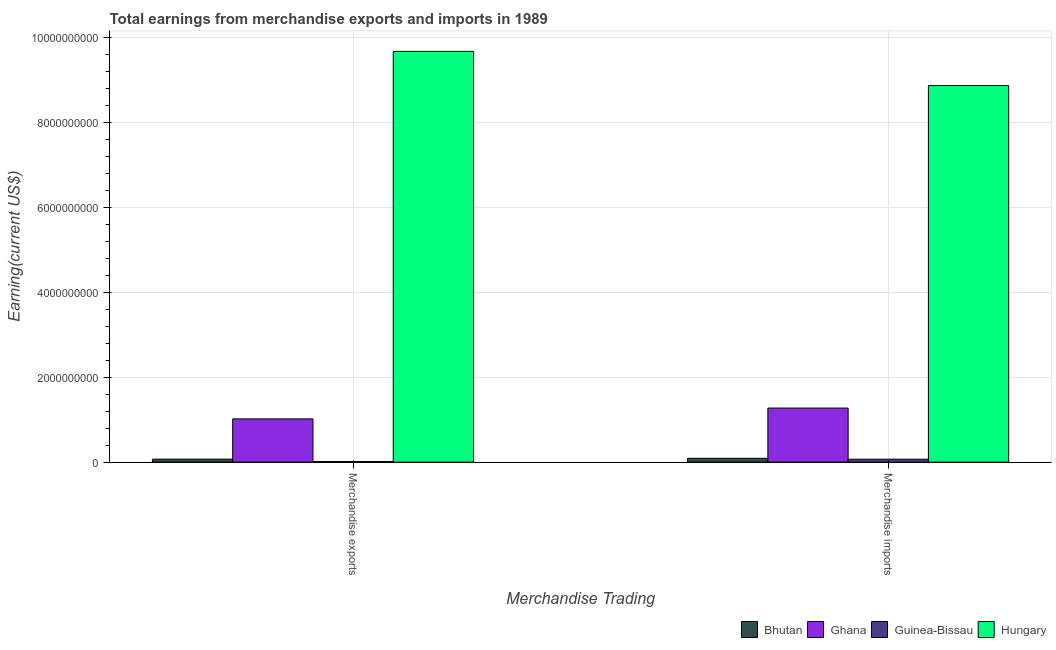What is the label of the 2nd group of bars from the left?
Make the answer very short. Merchandise imports. What is the earnings from merchandise exports in Guinea-Bissau?
Offer a terse response. 1.40e+07. Across all countries, what is the maximum earnings from merchandise exports?
Your response must be concise. 9.67e+09. Across all countries, what is the minimum earnings from merchandise imports?
Offer a very short reply. 6.90e+07. In which country was the earnings from merchandise exports maximum?
Give a very brief answer. Hungary. In which country was the earnings from merchandise exports minimum?
Ensure brevity in your answer.  Guinea-Bissau. What is the total earnings from merchandise imports in the graph?
Make the answer very short. 1.03e+1. What is the difference between the earnings from merchandise imports in Bhutan and that in Guinea-Bissau?
Your response must be concise. 2.10e+07. What is the difference between the earnings from merchandise exports in Guinea-Bissau and the earnings from merchandise imports in Ghana?
Keep it short and to the point. -1.26e+09. What is the average earnings from merchandise imports per country?
Offer a very short reply. 2.57e+09. What is the difference between the earnings from merchandise imports and earnings from merchandise exports in Bhutan?
Provide a short and direct response. 2.00e+07. In how many countries, is the earnings from merchandise exports greater than 6000000000 US$?
Your answer should be compact. 1. What is the ratio of the earnings from merchandise exports in Ghana to that in Bhutan?
Offer a terse response. 14.54. Is the earnings from merchandise imports in Ghana less than that in Bhutan?
Your response must be concise. No. In how many countries, is the earnings from merchandise exports greater than the average earnings from merchandise exports taken over all countries?
Provide a succinct answer. 1. What does the 1st bar from the left in Merchandise imports represents?
Give a very brief answer. Bhutan. What does the 2nd bar from the right in Merchandise exports represents?
Your answer should be very brief. Guinea-Bissau. How many countries are there in the graph?
Provide a succinct answer. 4. What is the difference between two consecutive major ticks on the Y-axis?
Make the answer very short. 2.00e+09. Where does the legend appear in the graph?
Ensure brevity in your answer.  Bottom right. How many legend labels are there?
Make the answer very short. 4. What is the title of the graph?
Give a very brief answer. Total earnings from merchandise exports and imports in 1989. Does "Hong Kong" appear as one of the legend labels in the graph?
Provide a succinct answer. No. What is the label or title of the X-axis?
Your response must be concise. Merchandise Trading. What is the label or title of the Y-axis?
Provide a short and direct response. Earning(current US$). What is the Earning(current US$) in Bhutan in Merchandise exports?
Give a very brief answer. 7.00e+07. What is the Earning(current US$) of Ghana in Merchandise exports?
Offer a terse response. 1.02e+09. What is the Earning(current US$) of Guinea-Bissau in Merchandise exports?
Your answer should be compact. 1.40e+07. What is the Earning(current US$) in Hungary in Merchandise exports?
Your answer should be very brief. 9.67e+09. What is the Earning(current US$) in Bhutan in Merchandise imports?
Provide a succinct answer. 9.00e+07. What is the Earning(current US$) in Ghana in Merchandise imports?
Offer a very short reply. 1.27e+09. What is the Earning(current US$) in Guinea-Bissau in Merchandise imports?
Provide a short and direct response. 6.90e+07. What is the Earning(current US$) of Hungary in Merchandise imports?
Your answer should be very brief. 8.86e+09. Across all Merchandise Trading, what is the maximum Earning(current US$) in Bhutan?
Provide a short and direct response. 9.00e+07. Across all Merchandise Trading, what is the maximum Earning(current US$) of Ghana?
Give a very brief answer. 1.27e+09. Across all Merchandise Trading, what is the maximum Earning(current US$) in Guinea-Bissau?
Your answer should be compact. 6.90e+07. Across all Merchandise Trading, what is the maximum Earning(current US$) of Hungary?
Offer a very short reply. 9.67e+09. Across all Merchandise Trading, what is the minimum Earning(current US$) of Bhutan?
Offer a terse response. 7.00e+07. Across all Merchandise Trading, what is the minimum Earning(current US$) in Ghana?
Keep it short and to the point. 1.02e+09. Across all Merchandise Trading, what is the minimum Earning(current US$) in Guinea-Bissau?
Offer a very short reply. 1.40e+07. Across all Merchandise Trading, what is the minimum Earning(current US$) of Hungary?
Provide a short and direct response. 8.86e+09. What is the total Earning(current US$) in Bhutan in the graph?
Your response must be concise. 1.60e+08. What is the total Earning(current US$) of Ghana in the graph?
Provide a succinct answer. 2.29e+09. What is the total Earning(current US$) in Guinea-Bissau in the graph?
Your answer should be compact. 8.30e+07. What is the total Earning(current US$) in Hungary in the graph?
Your response must be concise. 1.85e+1. What is the difference between the Earning(current US$) in Bhutan in Merchandise exports and that in Merchandise imports?
Keep it short and to the point. -2.00e+07. What is the difference between the Earning(current US$) of Ghana in Merchandise exports and that in Merchandise imports?
Provide a short and direct response. -2.55e+08. What is the difference between the Earning(current US$) of Guinea-Bissau in Merchandise exports and that in Merchandise imports?
Your answer should be compact. -5.50e+07. What is the difference between the Earning(current US$) of Hungary in Merchandise exports and that in Merchandise imports?
Your answer should be compact. 8.05e+08. What is the difference between the Earning(current US$) of Bhutan in Merchandise exports and the Earning(current US$) of Ghana in Merchandise imports?
Give a very brief answer. -1.20e+09. What is the difference between the Earning(current US$) in Bhutan in Merchandise exports and the Earning(current US$) in Guinea-Bissau in Merchandise imports?
Give a very brief answer. 1.00e+06. What is the difference between the Earning(current US$) in Bhutan in Merchandise exports and the Earning(current US$) in Hungary in Merchandise imports?
Ensure brevity in your answer.  -8.80e+09. What is the difference between the Earning(current US$) in Ghana in Merchandise exports and the Earning(current US$) in Guinea-Bissau in Merchandise imports?
Provide a short and direct response. 9.49e+08. What is the difference between the Earning(current US$) of Ghana in Merchandise exports and the Earning(current US$) of Hungary in Merchandise imports?
Make the answer very short. -7.85e+09. What is the difference between the Earning(current US$) of Guinea-Bissau in Merchandise exports and the Earning(current US$) of Hungary in Merchandise imports?
Keep it short and to the point. -8.85e+09. What is the average Earning(current US$) of Bhutan per Merchandise Trading?
Your response must be concise. 8.00e+07. What is the average Earning(current US$) of Ghana per Merchandise Trading?
Provide a short and direct response. 1.15e+09. What is the average Earning(current US$) in Guinea-Bissau per Merchandise Trading?
Offer a terse response. 4.15e+07. What is the average Earning(current US$) in Hungary per Merchandise Trading?
Your answer should be compact. 9.27e+09. What is the difference between the Earning(current US$) of Bhutan and Earning(current US$) of Ghana in Merchandise exports?
Keep it short and to the point. -9.48e+08. What is the difference between the Earning(current US$) of Bhutan and Earning(current US$) of Guinea-Bissau in Merchandise exports?
Offer a very short reply. 5.60e+07. What is the difference between the Earning(current US$) in Bhutan and Earning(current US$) in Hungary in Merchandise exports?
Ensure brevity in your answer.  -9.60e+09. What is the difference between the Earning(current US$) in Ghana and Earning(current US$) in Guinea-Bissau in Merchandise exports?
Make the answer very short. 1.00e+09. What is the difference between the Earning(current US$) of Ghana and Earning(current US$) of Hungary in Merchandise exports?
Give a very brief answer. -8.65e+09. What is the difference between the Earning(current US$) in Guinea-Bissau and Earning(current US$) in Hungary in Merchandise exports?
Offer a very short reply. -9.66e+09. What is the difference between the Earning(current US$) in Bhutan and Earning(current US$) in Ghana in Merchandise imports?
Your answer should be very brief. -1.18e+09. What is the difference between the Earning(current US$) of Bhutan and Earning(current US$) of Guinea-Bissau in Merchandise imports?
Provide a succinct answer. 2.10e+07. What is the difference between the Earning(current US$) of Bhutan and Earning(current US$) of Hungary in Merchandise imports?
Give a very brief answer. -8.78e+09. What is the difference between the Earning(current US$) in Ghana and Earning(current US$) in Guinea-Bissau in Merchandise imports?
Give a very brief answer. 1.20e+09. What is the difference between the Earning(current US$) of Ghana and Earning(current US$) of Hungary in Merchandise imports?
Ensure brevity in your answer.  -7.59e+09. What is the difference between the Earning(current US$) in Guinea-Bissau and Earning(current US$) in Hungary in Merchandise imports?
Offer a terse response. -8.80e+09. What is the ratio of the Earning(current US$) in Bhutan in Merchandise exports to that in Merchandise imports?
Give a very brief answer. 0.78. What is the ratio of the Earning(current US$) in Ghana in Merchandise exports to that in Merchandise imports?
Your answer should be compact. 0.8. What is the ratio of the Earning(current US$) in Guinea-Bissau in Merchandise exports to that in Merchandise imports?
Make the answer very short. 0.2. What is the ratio of the Earning(current US$) of Hungary in Merchandise exports to that in Merchandise imports?
Keep it short and to the point. 1.09. What is the difference between the highest and the second highest Earning(current US$) of Bhutan?
Make the answer very short. 2.00e+07. What is the difference between the highest and the second highest Earning(current US$) in Ghana?
Make the answer very short. 2.55e+08. What is the difference between the highest and the second highest Earning(current US$) in Guinea-Bissau?
Offer a very short reply. 5.50e+07. What is the difference between the highest and the second highest Earning(current US$) of Hungary?
Provide a succinct answer. 8.05e+08. What is the difference between the highest and the lowest Earning(current US$) in Ghana?
Your answer should be very brief. 2.55e+08. What is the difference between the highest and the lowest Earning(current US$) in Guinea-Bissau?
Keep it short and to the point. 5.50e+07. What is the difference between the highest and the lowest Earning(current US$) of Hungary?
Give a very brief answer. 8.05e+08. 